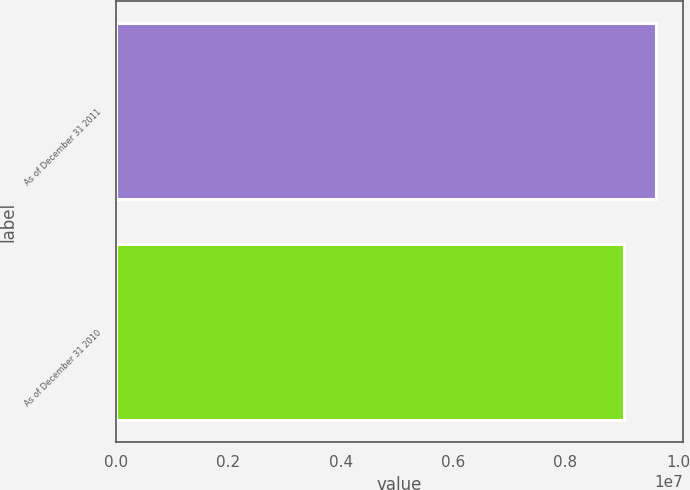Convert chart. <chart><loc_0><loc_0><loc_500><loc_500><bar_chart><fcel>As of December 31 2011<fcel>As of December 31 2010<nl><fcel>9.60802e+06<fcel>9.04933e+06<nl></chart> 